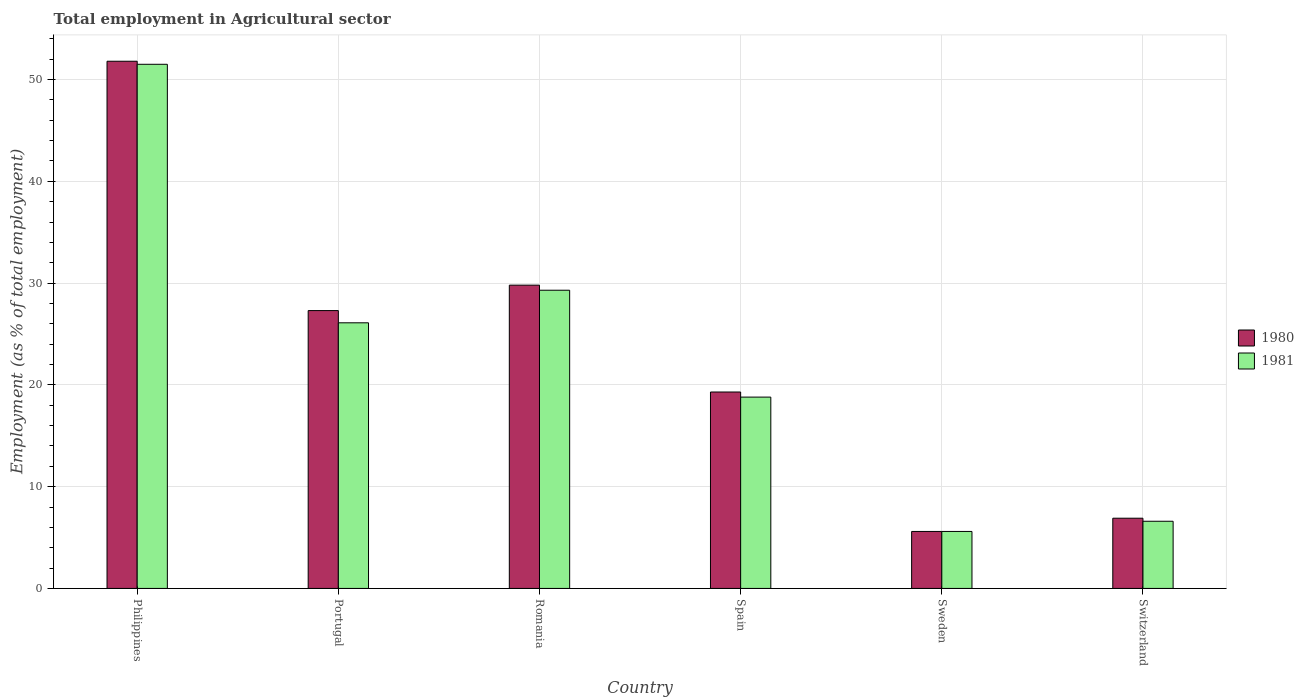How many different coloured bars are there?
Make the answer very short. 2. Are the number of bars on each tick of the X-axis equal?
Provide a short and direct response. Yes. What is the label of the 2nd group of bars from the left?
Your answer should be very brief. Portugal. In how many cases, is the number of bars for a given country not equal to the number of legend labels?
Provide a succinct answer. 0. What is the employment in agricultural sector in 1981 in Philippines?
Make the answer very short. 51.5. Across all countries, what is the maximum employment in agricultural sector in 1980?
Keep it short and to the point. 51.8. Across all countries, what is the minimum employment in agricultural sector in 1980?
Offer a very short reply. 5.6. In which country was the employment in agricultural sector in 1980 minimum?
Provide a succinct answer. Sweden. What is the total employment in agricultural sector in 1981 in the graph?
Ensure brevity in your answer.  137.9. What is the difference between the employment in agricultural sector in 1981 in Romania and that in Sweden?
Keep it short and to the point. 23.7. What is the difference between the employment in agricultural sector in 1980 in Philippines and the employment in agricultural sector in 1981 in Spain?
Give a very brief answer. 33. What is the average employment in agricultural sector in 1980 per country?
Give a very brief answer. 23.45. What is the difference between the employment in agricultural sector of/in 1981 and employment in agricultural sector of/in 1980 in Portugal?
Give a very brief answer. -1.2. In how many countries, is the employment in agricultural sector in 1980 greater than 24 %?
Give a very brief answer. 3. What is the ratio of the employment in agricultural sector in 1980 in Portugal to that in Spain?
Offer a terse response. 1.41. What is the difference between the highest and the second highest employment in agricultural sector in 1980?
Your answer should be compact. -24.5. What is the difference between the highest and the lowest employment in agricultural sector in 1980?
Ensure brevity in your answer.  46.2. What does the 2nd bar from the right in Sweden represents?
Your response must be concise. 1980. How many countries are there in the graph?
Keep it short and to the point. 6. How are the legend labels stacked?
Give a very brief answer. Vertical. What is the title of the graph?
Keep it short and to the point. Total employment in Agricultural sector. Does "2007" appear as one of the legend labels in the graph?
Offer a terse response. No. What is the label or title of the X-axis?
Ensure brevity in your answer.  Country. What is the label or title of the Y-axis?
Your answer should be compact. Employment (as % of total employment). What is the Employment (as % of total employment) in 1980 in Philippines?
Offer a terse response. 51.8. What is the Employment (as % of total employment) in 1981 in Philippines?
Your answer should be compact. 51.5. What is the Employment (as % of total employment) of 1980 in Portugal?
Make the answer very short. 27.3. What is the Employment (as % of total employment) in 1981 in Portugal?
Your response must be concise. 26.1. What is the Employment (as % of total employment) in 1980 in Romania?
Offer a very short reply. 29.8. What is the Employment (as % of total employment) of 1981 in Romania?
Provide a short and direct response. 29.3. What is the Employment (as % of total employment) in 1980 in Spain?
Your response must be concise. 19.3. What is the Employment (as % of total employment) of 1981 in Spain?
Your response must be concise. 18.8. What is the Employment (as % of total employment) of 1980 in Sweden?
Offer a very short reply. 5.6. What is the Employment (as % of total employment) in 1981 in Sweden?
Provide a succinct answer. 5.6. What is the Employment (as % of total employment) in 1980 in Switzerland?
Ensure brevity in your answer.  6.9. What is the Employment (as % of total employment) in 1981 in Switzerland?
Your response must be concise. 6.6. Across all countries, what is the maximum Employment (as % of total employment) of 1980?
Provide a short and direct response. 51.8. Across all countries, what is the maximum Employment (as % of total employment) of 1981?
Give a very brief answer. 51.5. Across all countries, what is the minimum Employment (as % of total employment) of 1980?
Provide a succinct answer. 5.6. Across all countries, what is the minimum Employment (as % of total employment) in 1981?
Ensure brevity in your answer.  5.6. What is the total Employment (as % of total employment) in 1980 in the graph?
Your answer should be very brief. 140.7. What is the total Employment (as % of total employment) of 1981 in the graph?
Offer a terse response. 137.9. What is the difference between the Employment (as % of total employment) in 1981 in Philippines and that in Portugal?
Your answer should be compact. 25.4. What is the difference between the Employment (as % of total employment) in 1980 in Philippines and that in Romania?
Keep it short and to the point. 22. What is the difference between the Employment (as % of total employment) of 1980 in Philippines and that in Spain?
Give a very brief answer. 32.5. What is the difference between the Employment (as % of total employment) in 1981 in Philippines and that in Spain?
Make the answer very short. 32.7. What is the difference between the Employment (as % of total employment) in 1980 in Philippines and that in Sweden?
Offer a very short reply. 46.2. What is the difference between the Employment (as % of total employment) of 1981 in Philippines and that in Sweden?
Your answer should be compact. 45.9. What is the difference between the Employment (as % of total employment) of 1980 in Philippines and that in Switzerland?
Offer a terse response. 44.9. What is the difference between the Employment (as % of total employment) in 1981 in Philippines and that in Switzerland?
Your answer should be very brief. 44.9. What is the difference between the Employment (as % of total employment) of 1980 in Portugal and that in Romania?
Make the answer very short. -2.5. What is the difference between the Employment (as % of total employment) of 1981 in Portugal and that in Spain?
Provide a succinct answer. 7.3. What is the difference between the Employment (as % of total employment) in 1980 in Portugal and that in Sweden?
Ensure brevity in your answer.  21.7. What is the difference between the Employment (as % of total employment) of 1980 in Portugal and that in Switzerland?
Give a very brief answer. 20.4. What is the difference between the Employment (as % of total employment) of 1980 in Romania and that in Sweden?
Provide a short and direct response. 24.2. What is the difference between the Employment (as % of total employment) in 1981 in Romania and that in Sweden?
Keep it short and to the point. 23.7. What is the difference between the Employment (as % of total employment) of 1980 in Romania and that in Switzerland?
Offer a terse response. 22.9. What is the difference between the Employment (as % of total employment) of 1981 in Romania and that in Switzerland?
Keep it short and to the point. 22.7. What is the difference between the Employment (as % of total employment) of 1980 in Spain and that in Sweden?
Ensure brevity in your answer.  13.7. What is the difference between the Employment (as % of total employment) of 1980 in Spain and that in Switzerland?
Your response must be concise. 12.4. What is the difference between the Employment (as % of total employment) of 1980 in Sweden and that in Switzerland?
Provide a short and direct response. -1.3. What is the difference between the Employment (as % of total employment) in 1980 in Philippines and the Employment (as % of total employment) in 1981 in Portugal?
Provide a succinct answer. 25.7. What is the difference between the Employment (as % of total employment) of 1980 in Philippines and the Employment (as % of total employment) of 1981 in Spain?
Give a very brief answer. 33. What is the difference between the Employment (as % of total employment) of 1980 in Philippines and the Employment (as % of total employment) of 1981 in Sweden?
Offer a very short reply. 46.2. What is the difference between the Employment (as % of total employment) of 1980 in Philippines and the Employment (as % of total employment) of 1981 in Switzerland?
Give a very brief answer. 45.2. What is the difference between the Employment (as % of total employment) in 1980 in Portugal and the Employment (as % of total employment) in 1981 in Spain?
Your answer should be compact. 8.5. What is the difference between the Employment (as % of total employment) of 1980 in Portugal and the Employment (as % of total employment) of 1981 in Sweden?
Your answer should be very brief. 21.7. What is the difference between the Employment (as % of total employment) of 1980 in Portugal and the Employment (as % of total employment) of 1981 in Switzerland?
Offer a very short reply. 20.7. What is the difference between the Employment (as % of total employment) in 1980 in Romania and the Employment (as % of total employment) in 1981 in Sweden?
Make the answer very short. 24.2. What is the difference between the Employment (as % of total employment) of 1980 in Romania and the Employment (as % of total employment) of 1981 in Switzerland?
Your answer should be compact. 23.2. What is the difference between the Employment (as % of total employment) in 1980 in Spain and the Employment (as % of total employment) in 1981 in Sweden?
Keep it short and to the point. 13.7. What is the difference between the Employment (as % of total employment) of 1980 in Spain and the Employment (as % of total employment) of 1981 in Switzerland?
Ensure brevity in your answer.  12.7. What is the average Employment (as % of total employment) in 1980 per country?
Offer a very short reply. 23.45. What is the average Employment (as % of total employment) in 1981 per country?
Keep it short and to the point. 22.98. What is the difference between the Employment (as % of total employment) in 1980 and Employment (as % of total employment) in 1981 in Philippines?
Provide a short and direct response. 0.3. What is the difference between the Employment (as % of total employment) of 1980 and Employment (as % of total employment) of 1981 in Portugal?
Offer a very short reply. 1.2. What is the difference between the Employment (as % of total employment) in 1980 and Employment (as % of total employment) in 1981 in Romania?
Make the answer very short. 0.5. What is the difference between the Employment (as % of total employment) of 1980 and Employment (as % of total employment) of 1981 in Spain?
Your answer should be compact. 0.5. What is the ratio of the Employment (as % of total employment) of 1980 in Philippines to that in Portugal?
Provide a short and direct response. 1.9. What is the ratio of the Employment (as % of total employment) of 1981 in Philippines to that in Portugal?
Provide a short and direct response. 1.97. What is the ratio of the Employment (as % of total employment) in 1980 in Philippines to that in Romania?
Offer a terse response. 1.74. What is the ratio of the Employment (as % of total employment) of 1981 in Philippines to that in Romania?
Give a very brief answer. 1.76. What is the ratio of the Employment (as % of total employment) of 1980 in Philippines to that in Spain?
Give a very brief answer. 2.68. What is the ratio of the Employment (as % of total employment) of 1981 in Philippines to that in Spain?
Provide a short and direct response. 2.74. What is the ratio of the Employment (as % of total employment) of 1980 in Philippines to that in Sweden?
Keep it short and to the point. 9.25. What is the ratio of the Employment (as % of total employment) in 1981 in Philippines to that in Sweden?
Give a very brief answer. 9.2. What is the ratio of the Employment (as % of total employment) in 1980 in Philippines to that in Switzerland?
Your answer should be compact. 7.51. What is the ratio of the Employment (as % of total employment) in 1981 in Philippines to that in Switzerland?
Your response must be concise. 7.8. What is the ratio of the Employment (as % of total employment) of 1980 in Portugal to that in Romania?
Make the answer very short. 0.92. What is the ratio of the Employment (as % of total employment) of 1981 in Portugal to that in Romania?
Your answer should be compact. 0.89. What is the ratio of the Employment (as % of total employment) in 1980 in Portugal to that in Spain?
Your response must be concise. 1.41. What is the ratio of the Employment (as % of total employment) of 1981 in Portugal to that in Spain?
Your answer should be very brief. 1.39. What is the ratio of the Employment (as % of total employment) of 1980 in Portugal to that in Sweden?
Your response must be concise. 4.88. What is the ratio of the Employment (as % of total employment) in 1981 in Portugal to that in Sweden?
Make the answer very short. 4.66. What is the ratio of the Employment (as % of total employment) in 1980 in Portugal to that in Switzerland?
Your response must be concise. 3.96. What is the ratio of the Employment (as % of total employment) in 1981 in Portugal to that in Switzerland?
Provide a short and direct response. 3.95. What is the ratio of the Employment (as % of total employment) of 1980 in Romania to that in Spain?
Your response must be concise. 1.54. What is the ratio of the Employment (as % of total employment) of 1981 in Romania to that in Spain?
Provide a succinct answer. 1.56. What is the ratio of the Employment (as % of total employment) of 1980 in Romania to that in Sweden?
Keep it short and to the point. 5.32. What is the ratio of the Employment (as % of total employment) in 1981 in Romania to that in Sweden?
Provide a short and direct response. 5.23. What is the ratio of the Employment (as % of total employment) of 1980 in Romania to that in Switzerland?
Keep it short and to the point. 4.32. What is the ratio of the Employment (as % of total employment) of 1981 in Romania to that in Switzerland?
Your response must be concise. 4.44. What is the ratio of the Employment (as % of total employment) of 1980 in Spain to that in Sweden?
Your answer should be compact. 3.45. What is the ratio of the Employment (as % of total employment) of 1981 in Spain to that in Sweden?
Give a very brief answer. 3.36. What is the ratio of the Employment (as % of total employment) in 1980 in Spain to that in Switzerland?
Make the answer very short. 2.8. What is the ratio of the Employment (as % of total employment) of 1981 in Spain to that in Switzerland?
Provide a short and direct response. 2.85. What is the ratio of the Employment (as % of total employment) in 1980 in Sweden to that in Switzerland?
Provide a succinct answer. 0.81. What is the ratio of the Employment (as % of total employment) of 1981 in Sweden to that in Switzerland?
Your answer should be very brief. 0.85. What is the difference between the highest and the lowest Employment (as % of total employment) of 1980?
Ensure brevity in your answer.  46.2. What is the difference between the highest and the lowest Employment (as % of total employment) of 1981?
Make the answer very short. 45.9. 